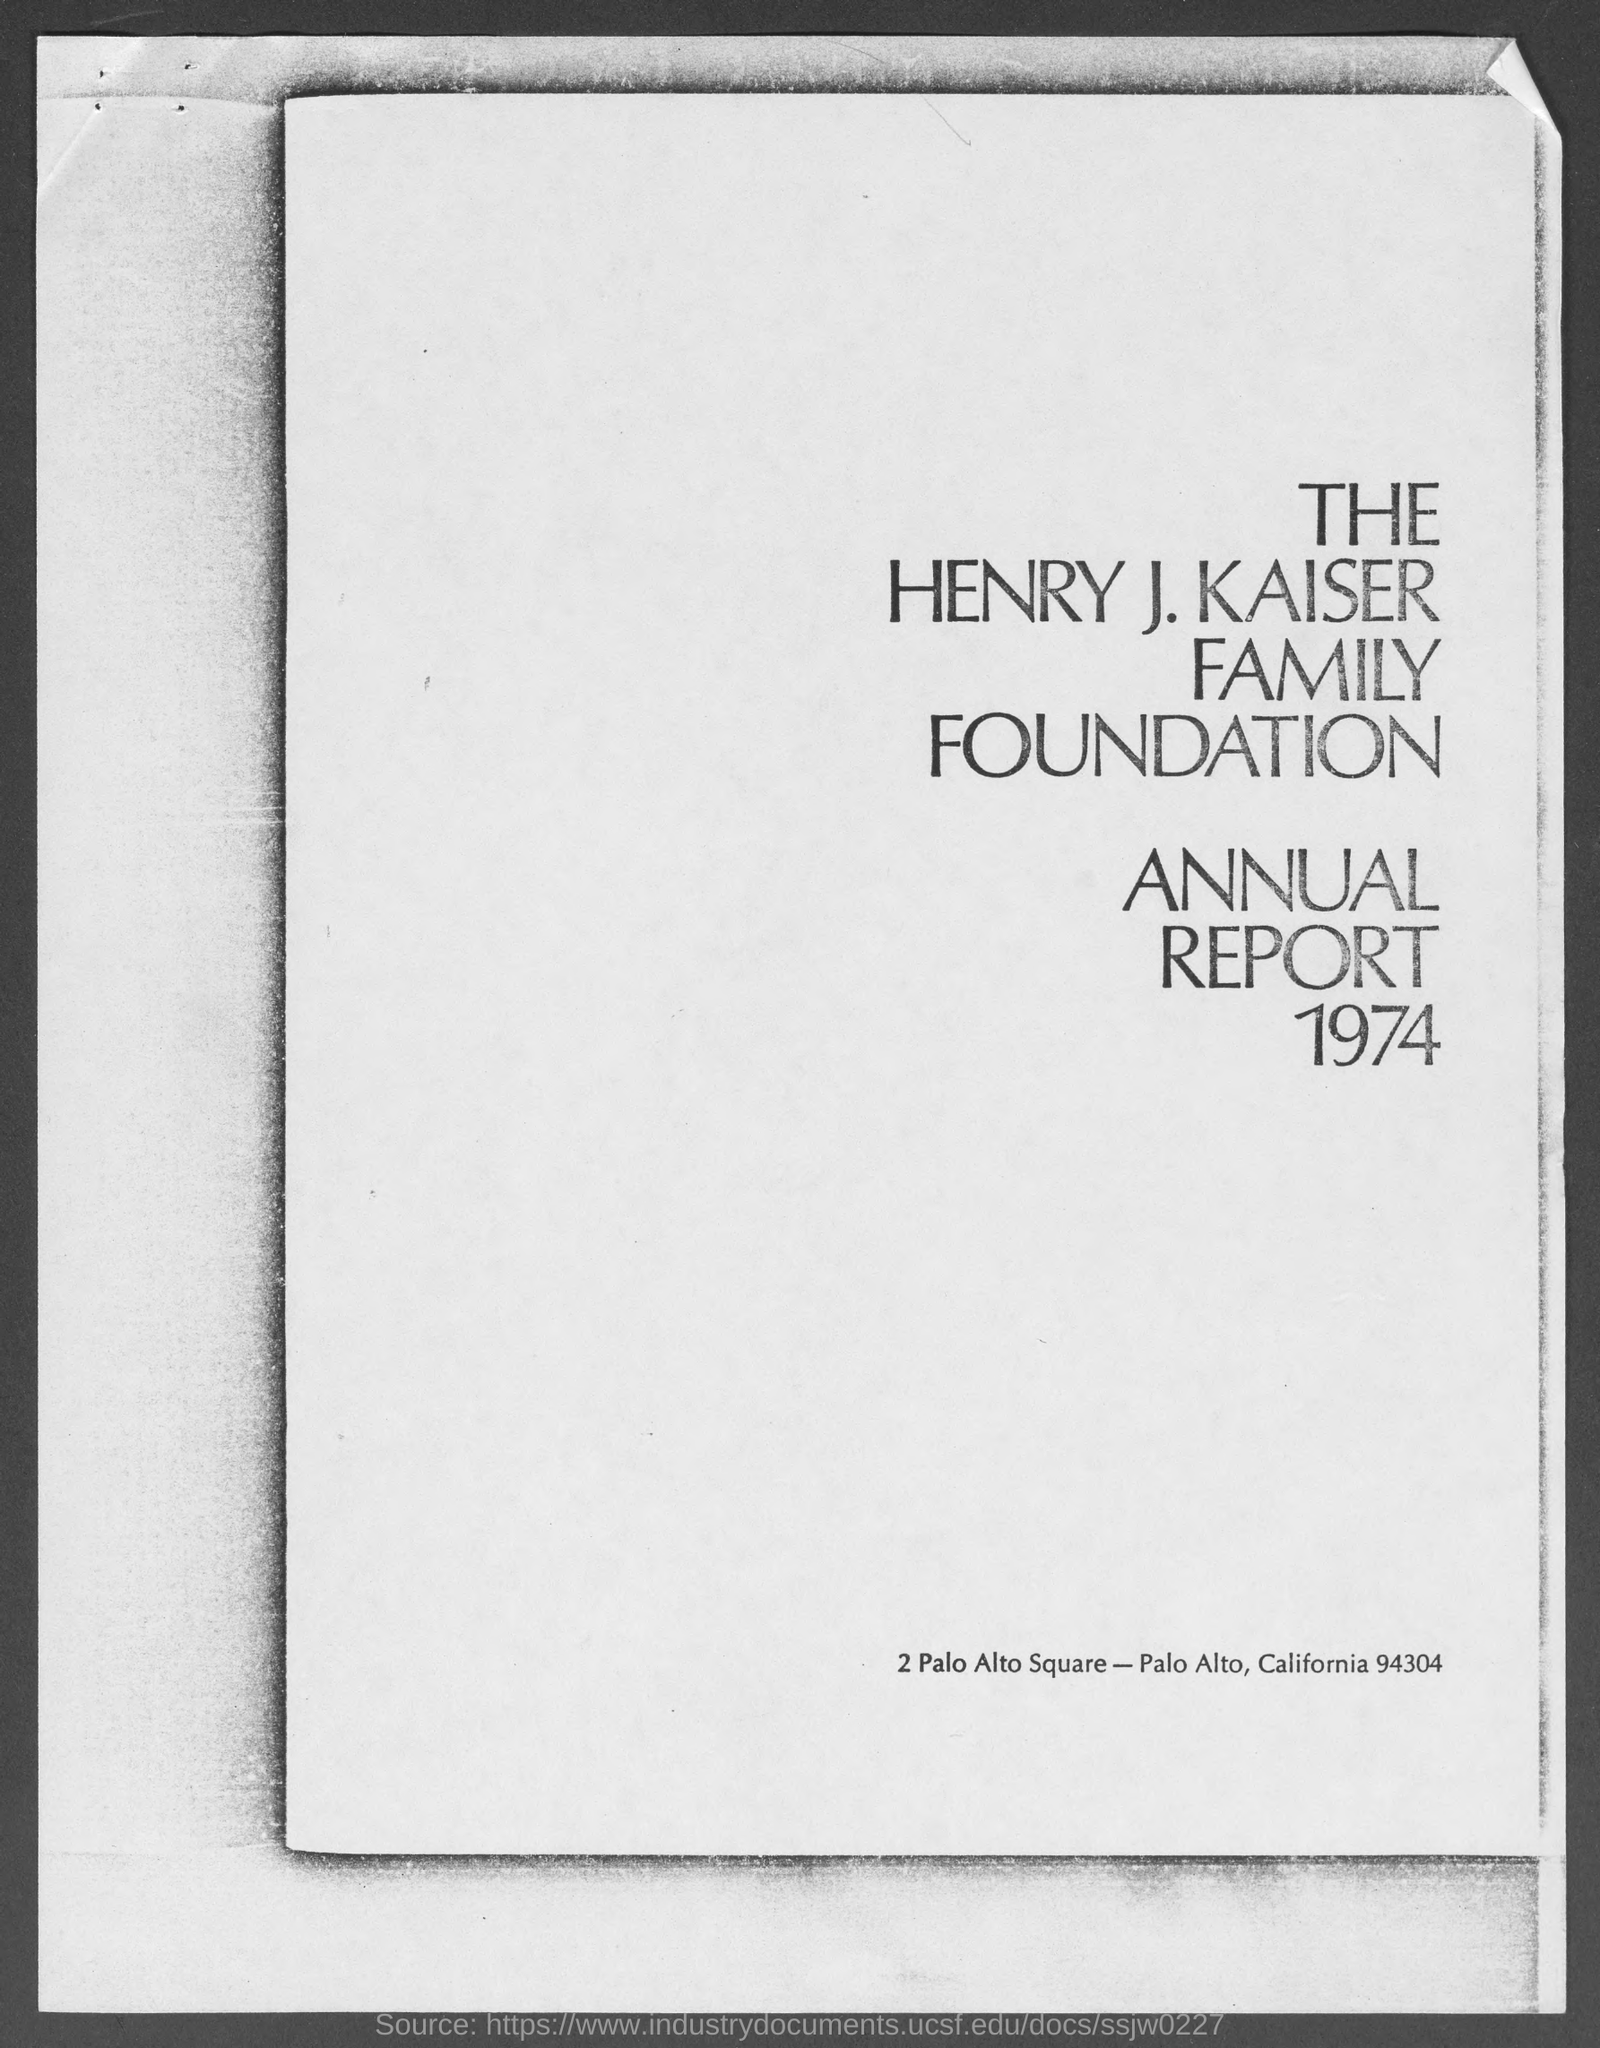Mention a couple of crucial points in this snapshot. The year that is written below the Annual Report is 1974. The Henry J. Kaiser Family Foundation is located at 2 Palo Alto Square, with a street address of [insert street address here]. 